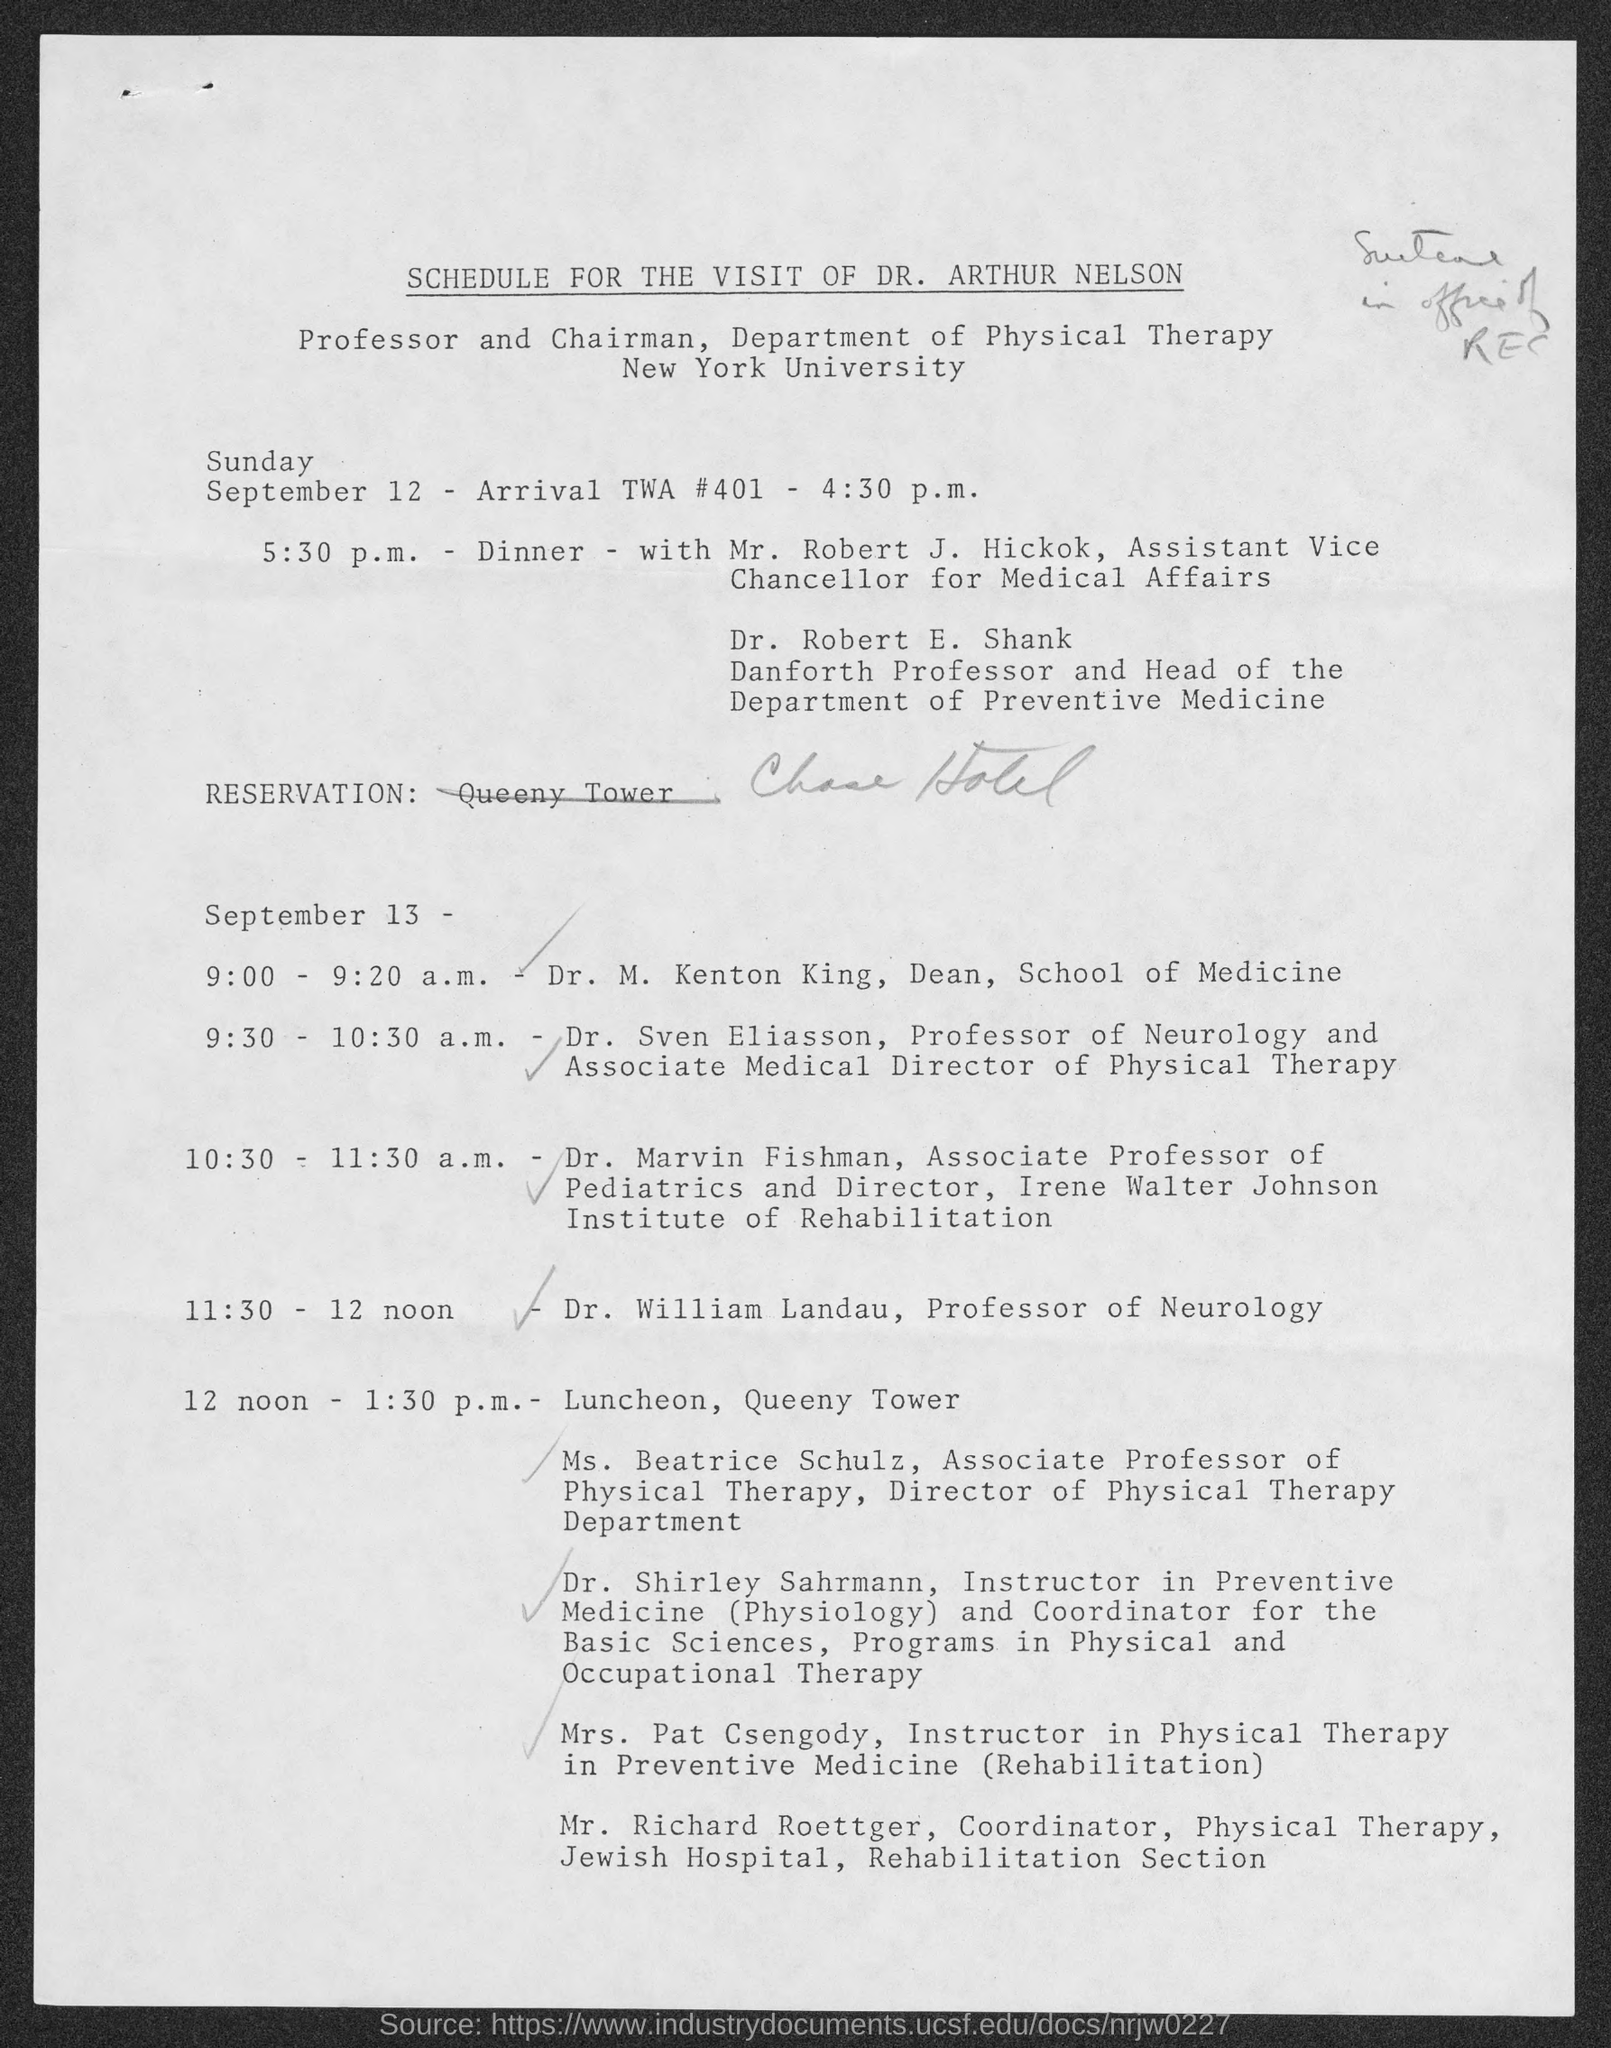What is the document title?
Offer a very short reply. Schedule for the visit of Dr. Arthur Nelson. Where is the luncheon?
Offer a very short reply. Queeny Tower. 